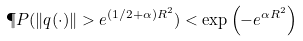<formula> <loc_0><loc_0><loc_500><loc_500>\P P ( \| q ( \cdot ) \| > e ^ { ( 1 / 2 + \alpha ) R ^ { 2 } } ) < \exp \left ( - e ^ { \alpha R ^ { 2 } } \right )</formula> 